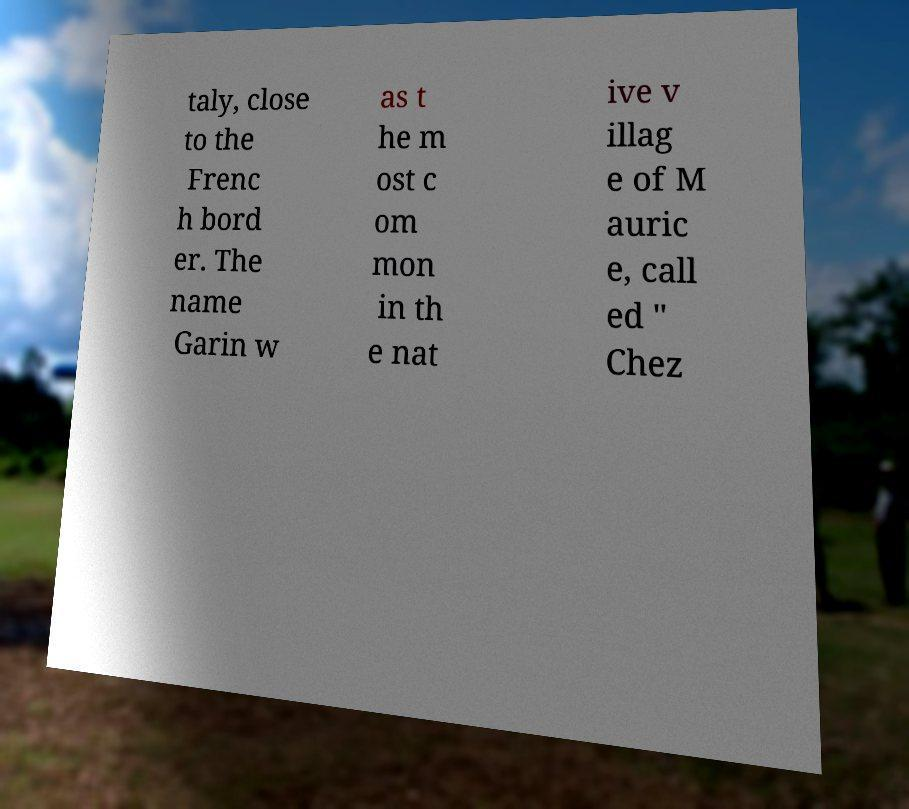There's text embedded in this image that I need extracted. Can you transcribe it verbatim? taly, close to the Frenc h bord er. The name Garin w as t he m ost c om mon in th e nat ive v illag e of M auric e, call ed " Chez 